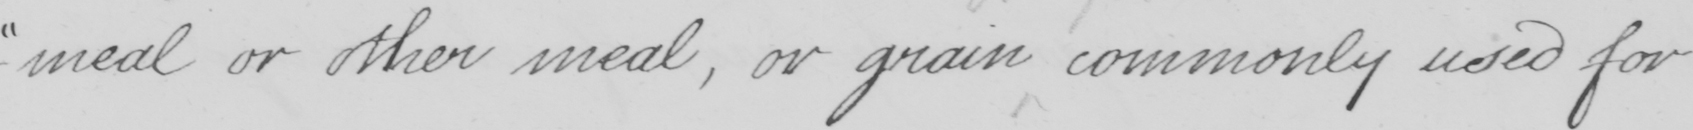Transcribe the text shown in this historical manuscript line. -meal or other meal , or grain commonly used for 